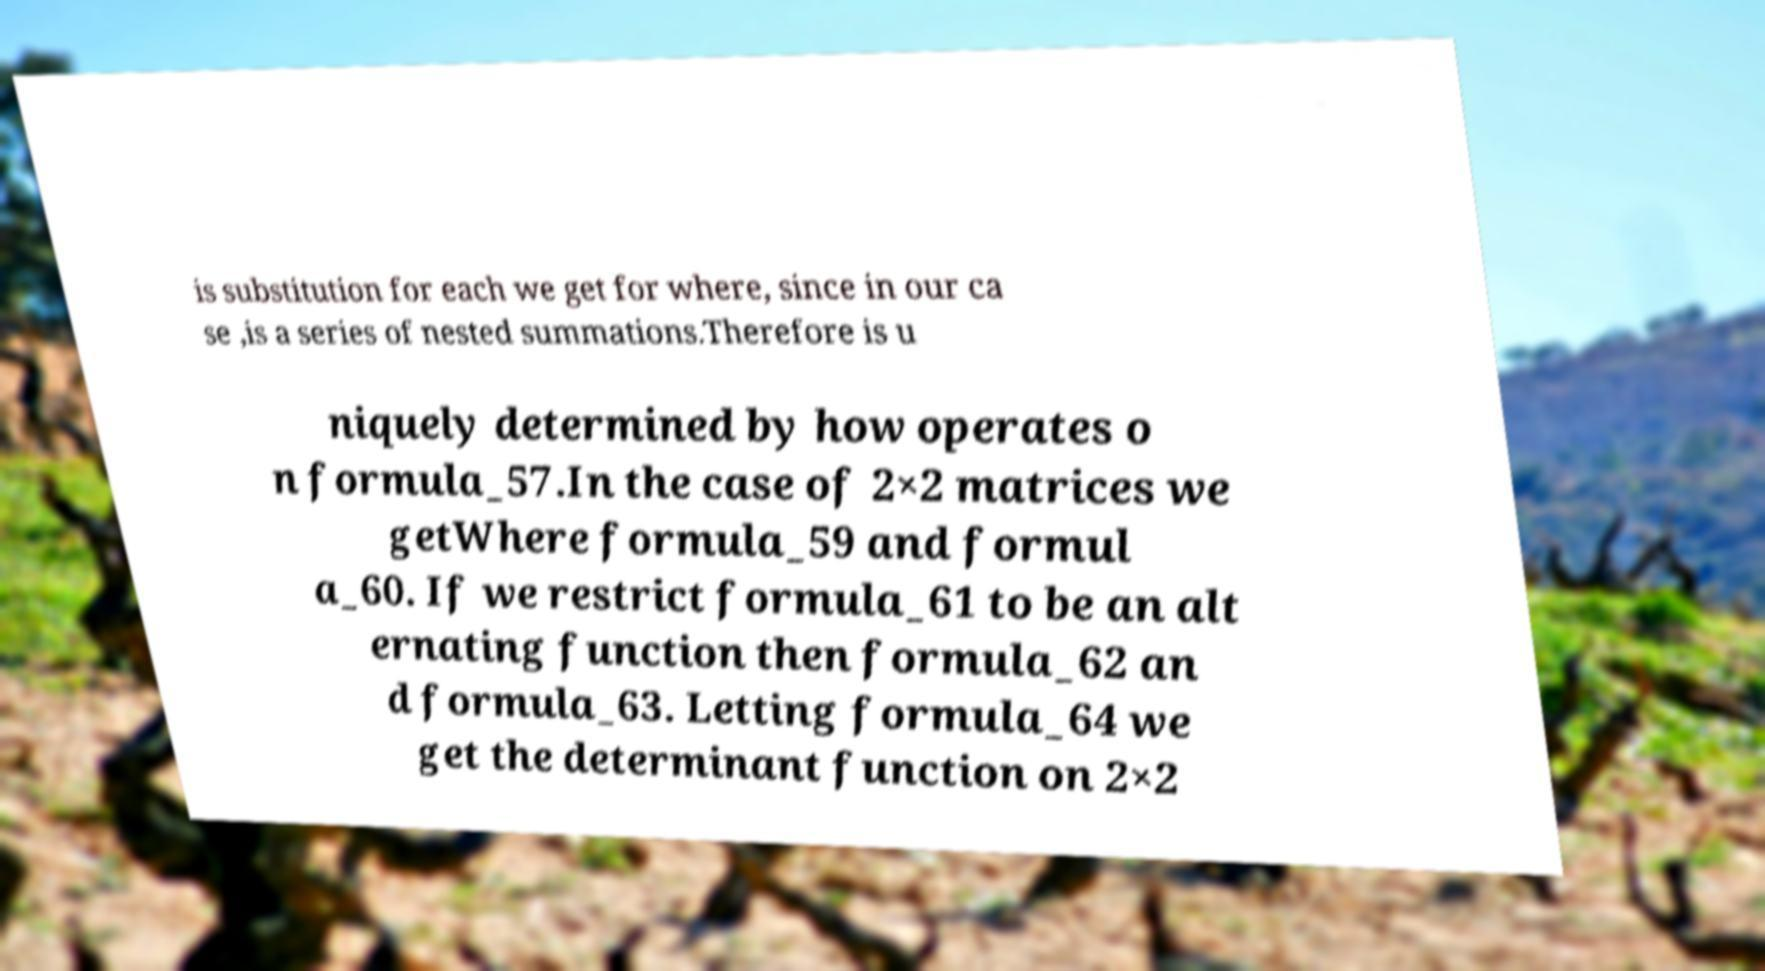I need the written content from this picture converted into text. Can you do that? is substitution for each we get for where, since in our ca se ,is a series of nested summations.Therefore is u niquely determined by how operates o n formula_57.In the case of 2×2 matrices we getWhere formula_59 and formul a_60. If we restrict formula_61 to be an alt ernating function then formula_62 an d formula_63. Letting formula_64 we get the determinant function on 2×2 